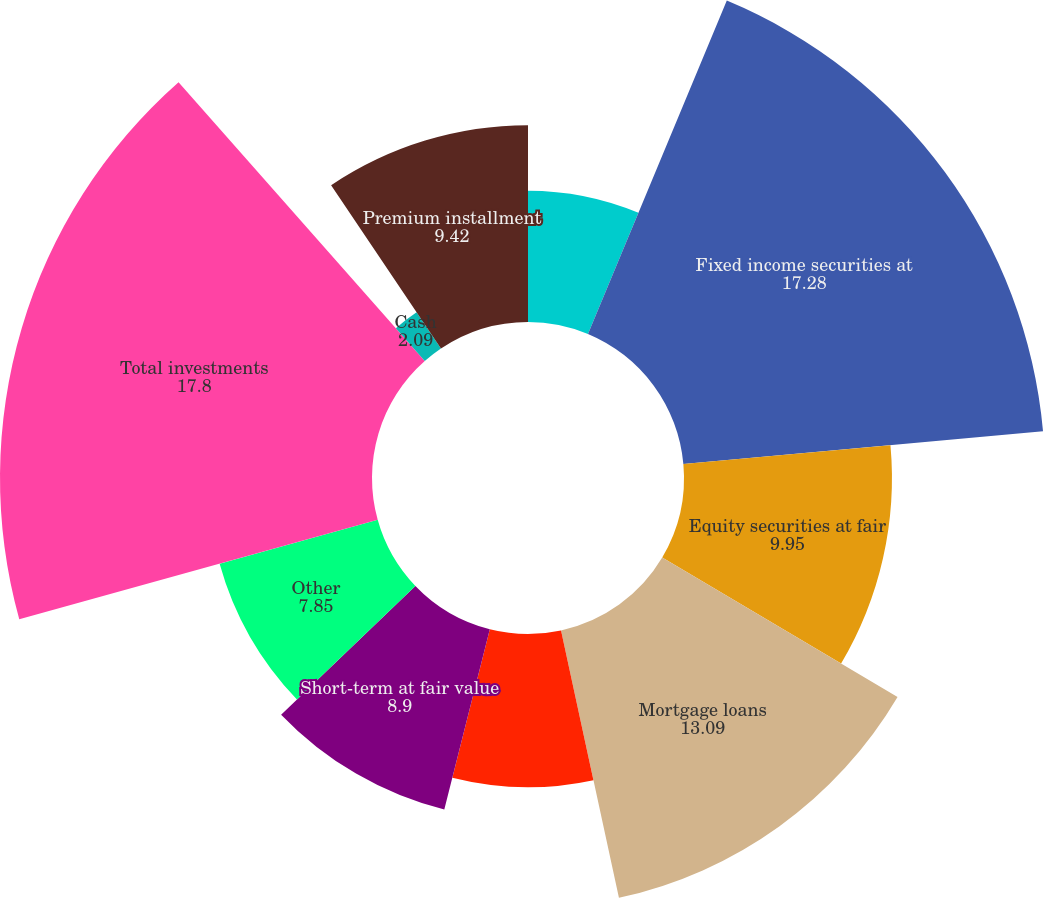Convert chart. <chart><loc_0><loc_0><loc_500><loc_500><pie_chart><fcel>( in millions except par value<fcel>Fixed income securities at<fcel>Equity securities at fair<fcel>Mortgage loans<fcel>Limited partnership interests<fcel>Short-term at fair value<fcel>Other<fcel>Total investments<fcel>Cash<fcel>Premium installment<nl><fcel>6.28%<fcel>17.28%<fcel>9.95%<fcel>13.09%<fcel>7.33%<fcel>8.9%<fcel>7.85%<fcel>17.8%<fcel>2.09%<fcel>9.42%<nl></chart> 